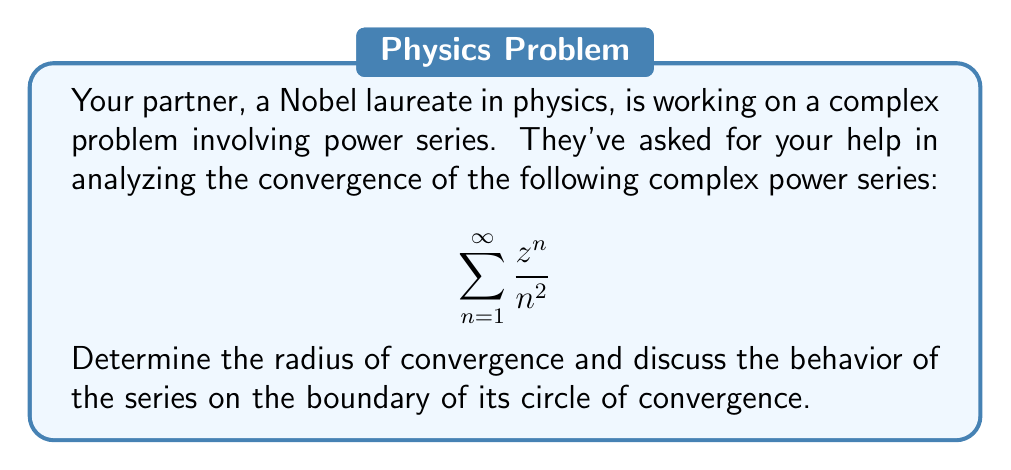Teach me how to tackle this problem. To analyze the convergence of this complex power series, we'll follow these steps:

1) First, let's determine the radius of convergence using the ratio test:

   $$\lim_{n \to \infty} \left|\frac{a_{n+1}}{a_n}\right| = \lim_{n \to \infty} \left|\frac{z^{n+1}/(n+1)^2}{z^n/n^2}\right| = \lim_{n \to \infty} \left|z\right| \cdot \frac{n^2}{(n+1)^2}$$

2) Simplify the limit:
   
   $$\lim_{n \to \infty} \left|z\right| \cdot \frac{n^2}{(n+1)^2} = \left|z\right| \cdot \lim_{n \to \infty} \frac{n^2}{(n+1)^2} = \left|z\right| \cdot 1 = \left|z\right|$$

3) For the series to converge, we need $\left|z\right| < 1$. Therefore, the radius of convergence is 1.

4) Now, let's examine the behavior on the boundary where $\left|z\right| = 1$:

   On the boundary, the series becomes:
   $$\sum_{n=1}^{\infty} \frac{e^{i\theta n}}{n^2}$$

   This is a Dirichlet series of the form $\sum_{n=1}^{\infty} \frac{a_n}{n^s}$ with $s=2$ and $a_n = e^{i\theta n}$.

5) By Dirichlet's test, this series converges for all real $\theta$ except when $\theta$ is a multiple of $2\pi$ (i.e., when $z=1$).

6) When $z=1$, the series becomes:
   $$\sum_{n=1}^{\infty} \frac{1}{n^2}$$
   This is the well-known Basel problem, which converges to $\frac{\pi^2}{6}$.

Therefore, the series converges for all $\left|z\right| \leq 1$, including the entire boundary of the circle of convergence, except for the point $z=1$.
Answer: The radius of convergence is 1. The series converges for all $\left|z\right| < 1$, and on the boundary $\left|z\right| = 1$ except at the point $z=1$. 